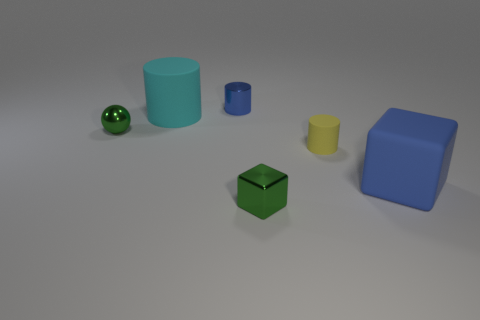Does the tiny metallic block have the same color as the tiny ball?
Give a very brief answer. Yes. Is the shape of the large matte thing in front of the cyan rubber object the same as the green metal thing that is right of the big cyan matte cylinder?
Provide a short and direct response. Yes. There is a yellow object that is the same shape as the large cyan thing; what is it made of?
Provide a succinct answer. Rubber. The tiny metal thing that is both in front of the big cylinder and behind the green block is what color?
Keep it short and to the point. Green. There is a rubber cube to the right of the metallic thing in front of the blue rubber cube; is there a blue object left of it?
Provide a succinct answer. Yes. What number of objects are either large cyan metal objects or blue cubes?
Give a very brief answer. 1. Does the large cube have the same material as the green object to the right of the small blue shiny cylinder?
Offer a terse response. No. Are there any other things of the same color as the tiny ball?
Your response must be concise. Yes. What number of things are matte objects to the left of the blue metal thing or tiny metal objects behind the blue matte thing?
Offer a very short reply. 3. There is a metallic thing that is both behind the yellow thing and to the right of the large cyan matte object; what is its shape?
Your answer should be compact. Cylinder. 